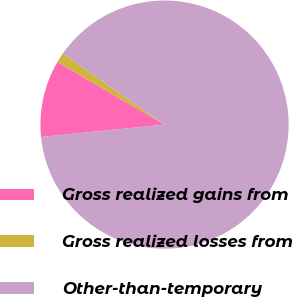Convert chart to OTSL. <chart><loc_0><loc_0><loc_500><loc_500><pie_chart><fcel>Gross realized gains from<fcel>Gross realized losses from<fcel>Other-than-temporary<nl><fcel>10.02%<fcel>1.28%<fcel>88.7%<nl></chart> 